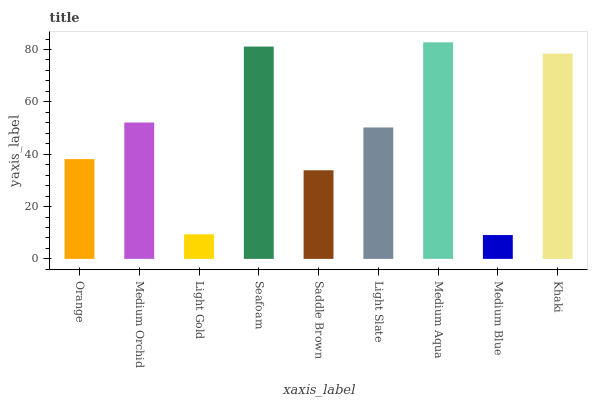Is Medium Blue the minimum?
Answer yes or no. Yes. Is Medium Aqua the maximum?
Answer yes or no. Yes. Is Medium Orchid the minimum?
Answer yes or no. No. Is Medium Orchid the maximum?
Answer yes or no. No. Is Medium Orchid greater than Orange?
Answer yes or no. Yes. Is Orange less than Medium Orchid?
Answer yes or no. Yes. Is Orange greater than Medium Orchid?
Answer yes or no. No. Is Medium Orchid less than Orange?
Answer yes or no. No. Is Light Slate the high median?
Answer yes or no. Yes. Is Light Slate the low median?
Answer yes or no. Yes. Is Seafoam the high median?
Answer yes or no. No. Is Medium Orchid the low median?
Answer yes or no. No. 